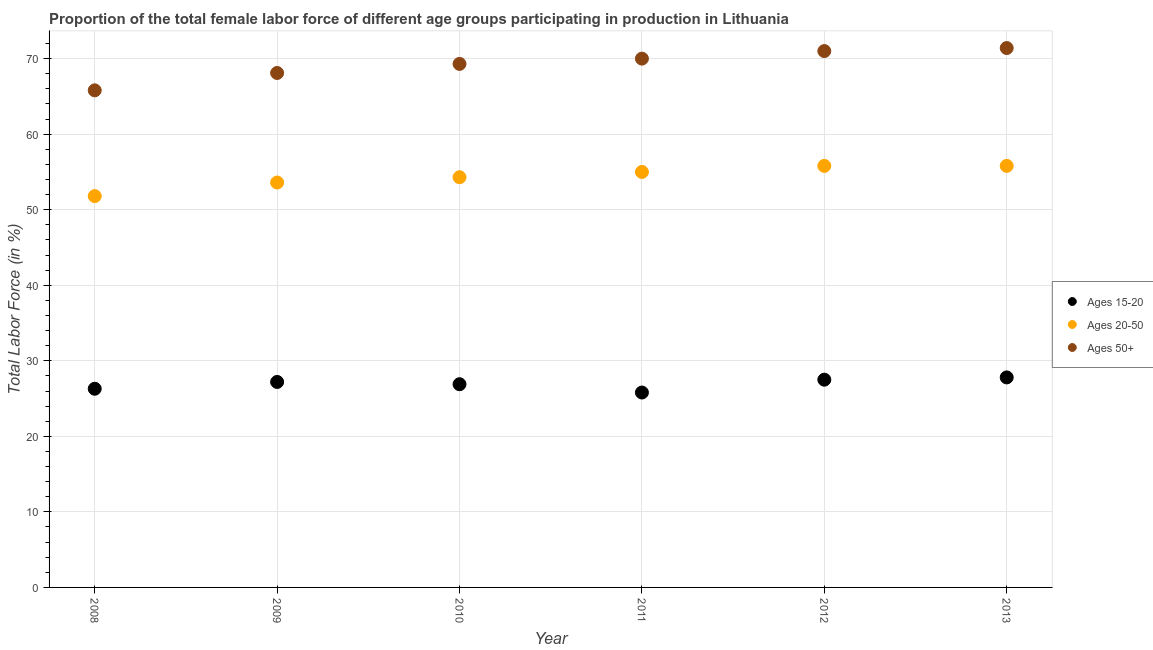How many different coloured dotlines are there?
Make the answer very short. 3. What is the percentage of female labor force within the age group 15-20 in 2011?
Provide a succinct answer. 25.8. Across all years, what is the maximum percentage of female labor force within the age group 20-50?
Your answer should be very brief. 55.8. Across all years, what is the minimum percentage of female labor force above age 50?
Your response must be concise. 65.8. What is the total percentage of female labor force above age 50 in the graph?
Your answer should be compact. 415.6. What is the difference between the percentage of female labor force within the age group 20-50 in 2009 and that in 2010?
Provide a succinct answer. -0.7. What is the difference between the percentage of female labor force within the age group 15-20 in 2008 and the percentage of female labor force within the age group 20-50 in 2009?
Give a very brief answer. -27.3. What is the average percentage of female labor force within the age group 15-20 per year?
Your response must be concise. 26.92. In the year 2012, what is the difference between the percentage of female labor force within the age group 20-50 and percentage of female labor force above age 50?
Offer a terse response. -15.2. What is the ratio of the percentage of female labor force within the age group 20-50 in 2008 to that in 2013?
Provide a succinct answer. 0.93. Is the percentage of female labor force above age 50 in 2011 less than that in 2012?
Make the answer very short. Yes. What is the difference between the highest and the second highest percentage of female labor force within the age group 15-20?
Offer a terse response. 0.3. What is the difference between the highest and the lowest percentage of female labor force within the age group 15-20?
Give a very brief answer. 2. Is the sum of the percentage of female labor force within the age group 15-20 in 2008 and 2011 greater than the maximum percentage of female labor force within the age group 20-50 across all years?
Your answer should be compact. No. Does the percentage of female labor force within the age group 15-20 monotonically increase over the years?
Give a very brief answer. No. Is the percentage of female labor force within the age group 20-50 strictly greater than the percentage of female labor force within the age group 15-20 over the years?
Make the answer very short. Yes. What is the difference between two consecutive major ticks on the Y-axis?
Give a very brief answer. 10. Are the values on the major ticks of Y-axis written in scientific E-notation?
Offer a very short reply. No. Where does the legend appear in the graph?
Keep it short and to the point. Center right. How many legend labels are there?
Give a very brief answer. 3. How are the legend labels stacked?
Your response must be concise. Vertical. What is the title of the graph?
Provide a short and direct response. Proportion of the total female labor force of different age groups participating in production in Lithuania. Does "Argument" appear as one of the legend labels in the graph?
Offer a terse response. No. What is the label or title of the X-axis?
Your answer should be very brief. Year. What is the label or title of the Y-axis?
Your answer should be compact. Total Labor Force (in %). What is the Total Labor Force (in %) in Ages 15-20 in 2008?
Keep it short and to the point. 26.3. What is the Total Labor Force (in %) of Ages 20-50 in 2008?
Your answer should be compact. 51.8. What is the Total Labor Force (in %) in Ages 50+ in 2008?
Offer a terse response. 65.8. What is the Total Labor Force (in %) in Ages 15-20 in 2009?
Make the answer very short. 27.2. What is the Total Labor Force (in %) in Ages 20-50 in 2009?
Make the answer very short. 53.6. What is the Total Labor Force (in %) of Ages 50+ in 2009?
Your answer should be compact. 68.1. What is the Total Labor Force (in %) of Ages 15-20 in 2010?
Give a very brief answer. 26.9. What is the Total Labor Force (in %) of Ages 20-50 in 2010?
Provide a short and direct response. 54.3. What is the Total Labor Force (in %) in Ages 50+ in 2010?
Your response must be concise. 69.3. What is the Total Labor Force (in %) in Ages 15-20 in 2011?
Ensure brevity in your answer.  25.8. What is the Total Labor Force (in %) of Ages 20-50 in 2012?
Provide a succinct answer. 55.8. What is the Total Labor Force (in %) in Ages 50+ in 2012?
Your answer should be very brief. 71. What is the Total Labor Force (in %) in Ages 15-20 in 2013?
Provide a succinct answer. 27.8. What is the Total Labor Force (in %) of Ages 20-50 in 2013?
Give a very brief answer. 55.8. What is the Total Labor Force (in %) in Ages 50+ in 2013?
Offer a very short reply. 71.4. Across all years, what is the maximum Total Labor Force (in %) in Ages 15-20?
Your answer should be compact. 27.8. Across all years, what is the maximum Total Labor Force (in %) in Ages 20-50?
Offer a very short reply. 55.8. Across all years, what is the maximum Total Labor Force (in %) in Ages 50+?
Keep it short and to the point. 71.4. Across all years, what is the minimum Total Labor Force (in %) in Ages 15-20?
Keep it short and to the point. 25.8. Across all years, what is the minimum Total Labor Force (in %) in Ages 20-50?
Your answer should be very brief. 51.8. Across all years, what is the minimum Total Labor Force (in %) in Ages 50+?
Make the answer very short. 65.8. What is the total Total Labor Force (in %) in Ages 15-20 in the graph?
Your answer should be compact. 161.5. What is the total Total Labor Force (in %) in Ages 20-50 in the graph?
Offer a terse response. 326.3. What is the total Total Labor Force (in %) of Ages 50+ in the graph?
Make the answer very short. 415.6. What is the difference between the Total Labor Force (in %) of Ages 20-50 in 2008 and that in 2010?
Give a very brief answer. -2.5. What is the difference between the Total Labor Force (in %) in Ages 50+ in 2008 and that in 2010?
Ensure brevity in your answer.  -3.5. What is the difference between the Total Labor Force (in %) of Ages 15-20 in 2008 and that in 2011?
Provide a short and direct response. 0.5. What is the difference between the Total Labor Force (in %) in Ages 50+ in 2008 and that in 2012?
Your answer should be compact. -5.2. What is the difference between the Total Labor Force (in %) of Ages 15-20 in 2009 and that in 2010?
Your answer should be very brief. 0.3. What is the difference between the Total Labor Force (in %) of Ages 20-50 in 2009 and that in 2010?
Your answer should be compact. -0.7. What is the difference between the Total Labor Force (in %) of Ages 50+ in 2009 and that in 2010?
Your answer should be compact. -1.2. What is the difference between the Total Labor Force (in %) of Ages 15-20 in 2009 and that in 2011?
Provide a succinct answer. 1.4. What is the difference between the Total Labor Force (in %) in Ages 50+ in 2009 and that in 2011?
Give a very brief answer. -1.9. What is the difference between the Total Labor Force (in %) of Ages 20-50 in 2009 and that in 2012?
Your response must be concise. -2.2. What is the difference between the Total Labor Force (in %) in Ages 50+ in 2009 and that in 2012?
Your response must be concise. -2.9. What is the difference between the Total Labor Force (in %) in Ages 20-50 in 2009 and that in 2013?
Offer a very short reply. -2.2. What is the difference between the Total Labor Force (in %) of Ages 50+ in 2009 and that in 2013?
Offer a terse response. -3.3. What is the difference between the Total Labor Force (in %) of Ages 20-50 in 2010 and that in 2011?
Provide a short and direct response. -0.7. What is the difference between the Total Labor Force (in %) in Ages 50+ in 2010 and that in 2011?
Provide a succinct answer. -0.7. What is the difference between the Total Labor Force (in %) of Ages 50+ in 2010 and that in 2012?
Your answer should be compact. -1.7. What is the difference between the Total Labor Force (in %) in Ages 20-50 in 2010 and that in 2013?
Make the answer very short. -1.5. What is the difference between the Total Labor Force (in %) of Ages 15-20 in 2011 and that in 2012?
Your answer should be compact. -1.7. What is the difference between the Total Labor Force (in %) of Ages 50+ in 2011 and that in 2012?
Offer a very short reply. -1. What is the difference between the Total Labor Force (in %) of Ages 50+ in 2011 and that in 2013?
Your response must be concise. -1.4. What is the difference between the Total Labor Force (in %) in Ages 20-50 in 2012 and that in 2013?
Keep it short and to the point. 0. What is the difference between the Total Labor Force (in %) in Ages 15-20 in 2008 and the Total Labor Force (in %) in Ages 20-50 in 2009?
Your answer should be compact. -27.3. What is the difference between the Total Labor Force (in %) of Ages 15-20 in 2008 and the Total Labor Force (in %) of Ages 50+ in 2009?
Your response must be concise. -41.8. What is the difference between the Total Labor Force (in %) in Ages 20-50 in 2008 and the Total Labor Force (in %) in Ages 50+ in 2009?
Make the answer very short. -16.3. What is the difference between the Total Labor Force (in %) in Ages 15-20 in 2008 and the Total Labor Force (in %) in Ages 50+ in 2010?
Your answer should be very brief. -43. What is the difference between the Total Labor Force (in %) of Ages 20-50 in 2008 and the Total Labor Force (in %) of Ages 50+ in 2010?
Provide a short and direct response. -17.5. What is the difference between the Total Labor Force (in %) of Ages 15-20 in 2008 and the Total Labor Force (in %) of Ages 20-50 in 2011?
Offer a terse response. -28.7. What is the difference between the Total Labor Force (in %) in Ages 15-20 in 2008 and the Total Labor Force (in %) in Ages 50+ in 2011?
Your answer should be very brief. -43.7. What is the difference between the Total Labor Force (in %) in Ages 20-50 in 2008 and the Total Labor Force (in %) in Ages 50+ in 2011?
Provide a succinct answer. -18.2. What is the difference between the Total Labor Force (in %) in Ages 15-20 in 2008 and the Total Labor Force (in %) in Ages 20-50 in 2012?
Your answer should be compact. -29.5. What is the difference between the Total Labor Force (in %) of Ages 15-20 in 2008 and the Total Labor Force (in %) of Ages 50+ in 2012?
Your answer should be compact. -44.7. What is the difference between the Total Labor Force (in %) in Ages 20-50 in 2008 and the Total Labor Force (in %) in Ages 50+ in 2012?
Keep it short and to the point. -19.2. What is the difference between the Total Labor Force (in %) of Ages 15-20 in 2008 and the Total Labor Force (in %) of Ages 20-50 in 2013?
Give a very brief answer. -29.5. What is the difference between the Total Labor Force (in %) in Ages 15-20 in 2008 and the Total Labor Force (in %) in Ages 50+ in 2013?
Your answer should be very brief. -45.1. What is the difference between the Total Labor Force (in %) of Ages 20-50 in 2008 and the Total Labor Force (in %) of Ages 50+ in 2013?
Your answer should be compact. -19.6. What is the difference between the Total Labor Force (in %) in Ages 15-20 in 2009 and the Total Labor Force (in %) in Ages 20-50 in 2010?
Your answer should be compact. -27.1. What is the difference between the Total Labor Force (in %) of Ages 15-20 in 2009 and the Total Labor Force (in %) of Ages 50+ in 2010?
Provide a short and direct response. -42.1. What is the difference between the Total Labor Force (in %) in Ages 20-50 in 2009 and the Total Labor Force (in %) in Ages 50+ in 2010?
Ensure brevity in your answer.  -15.7. What is the difference between the Total Labor Force (in %) of Ages 15-20 in 2009 and the Total Labor Force (in %) of Ages 20-50 in 2011?
Offer a very short reply. -27.8. What is the difference between the Total Labor Force (in %) in Ages 15-20 in 2009 and the Total Labor Force (in %) in Ages 50+ in 2011?
Your response must be concise. -42.8. What is the difference between the Total Labor Force (in %) in Ages 20-50 in 2009 and the Total Labor Force (in %) in Ages 50+ in 2011?
Provide a succinct answer. -16.4. What is the difference between the Total Labor Force (in %) of Ages 15-20 in 2009 and the Total Labor Force (in %) of Ages 20-50 in 2012?
Give a very brief answer. -28.6. What is the difference between the Total Labor Force (in %) of Ages 15-20 in 2009 and the Total Labor Force (in %) of Ages 50+ in 2012?
Your answer should be very brief. -43.8. What is the difference between the Total Labor Force (in %) of Ages 20-50 in 2009 and the Total Labor Force (in %) of Ages 50+ in 2012?
Keep it short and to the point. -17.4. What is the difference between the Total Labor Force (in %) of Ages 15-20 in 2009 and the Total Labor Force (in %) of Ages 20-50 in 2013?
Provide a short and direct response. -28.6. What is the difference between the Total Labor Force (in %) in Ages 15-20 in 2009 and the Total Labor Force (in %) in Ages 50+ in 2013?
Give a very brief answer. -44.2. What is the difference between the Total Labor Force (in %) of Ages 20-50 in 2009 and the Total Labor Force (in %) of Ages 50+ in 2013?
Offer a very short reply. -17.8. What is the difference between the Total Labor Force (in %) of Ages 15-20 in 2010 and the Total Labor Force (in %) of Ages 20-50 in 2011?
Your response must be concise. -28.1. What is the difference between the Total Labor Force (in %) of Ages 15-20 in 2010 and the Total Labor Force (in %) of Ages 50+ in 2011?
Your answer should be compact. -43.1. What is the difference between the Total Labor Force (in %) in Ages 20-50 in 2010 and the Total Labor Force (in %) in Ages 50+ in 2011?
Provide a succinct answer. -15.7. What is the difference between the Total Labor Force (in %) in Ages 15-20 in 2010 and the Total Labor Force (in %) in Ages 20-50 in 2012?
Your response must be concise. -28.9. What is the difference between the Total Labor Force (in %) of Ages 15-20 in 2010 and the Total Labor Force (in %) of Ages 50+ in 2012?
Give a very brief answer. -44.1. What is the difference between the Total Labor Force (in %) of Ages 20-50 in 2010 and the Total Labor Force (in %) of Ages 50+ in 2012?
Your response must be concise. -16.7. What is the difference between the Total Labor Force (in %) of Ages 15-20 in 2010 and the Total Labor Force (in %) of Ages 20-50 in 2013?
Your answer should be compact. -28.9. What is the difference between the Total Labor Force (in %) in Ages 15-20 in 2010 and the Total Labor Force (in %) in Ages 50+ in 2013?
Your answer should be compact. -44.5. What is the difference between the Total Labor Force (in %) of Ages 20-50 in 2010 and the Total Labor Force (in %) of Ages 50+ in 2013?
Provide a succinct answer. -17.1. What is the difference between the Total Labor Force (in %) of Ages 15-20 in 2011 and the Total Labor Force (in %) of Ages 20-50 in 2012?
Offer a very short reply. -30. What is the difference between the Total Labor Force (in %) of Ages 15-20 in 2011 and the Total Labor Force (in %) of Ages 50+ in 2012?
Provide a succinct answer. -45.2. What is the difference between the Total Labor Force (in %) of Ages 20-50 in 2011 and the Total Labor Force (in %) of Ages 50+ in 2012?
Provide a succinct answer. -16. What is the difference between the Total Labor Force (in %) of Ages 15-20 in 2011 and the Total Labor Force (in %) of Ages 50+ in 2013?
Give a very brief answer. -45.6. What is the difference between the Total Labor Force (in %) of Ages 20-50 in 2011 and the Total Labor Force (in %) of Ages 50+ in 2013?
Keep it short and to the point. -16.4. What is the difference between the Total Labor Force (in %) of Ages 15-20 in 2012 and the Total Labor Force (in %) of Ages 20-50 in 2013?
Give a very brief answer. -28.3. What is the difference between the Total Labor Force (in %) of Ages 15-20 in 2012 and the Total Labor Force (in %) of Ages 50+ in 2013?
Give a very brief answer. -43.9. What is the difference between the Total Labor Force (in %) in Ages 20-50 in 2012 and the Total Labor Force (in %) in Ages 50+ in 2013?
Offer a very short reply. -15.6. What is the average Total Labor Force (in %) in Ages 15-20 per year?
Your answer should be compact. 26.92. What is the average Total Labor Force (in %) in Ages 20-50 per year?
Give a very brief answer. 54.38. What is the average Total Labor Force (in %) in Ages 50+ per year?
Your answer should be very brief. 69.27. In the year 2008, what is the difference between the Total Labor Force (in %) of Ages 15-20 and Total Labor Force (in %) of Ages 20-50?
Make the answer very short. -25.5. In the year 2008, what is the difference between the Total Labor Force (in %) of Ages 15-20 and Total Labor Force (in %) of Ages 50+?
Make the answer very short. -39.5. In the year 2009, what is the difference between the Total Labor Force (in %) in Ages 15-20 and Total Labor Force (in %) in Ages 20-50?
Your answer should be compact. -26.4. In the year 2009, what is the difference between the Total Labor Force (in %) of Ages 15-20 and Total Labor Force (in %) of Ages 50+?
Make the answer very short. -40.9. In the year 2009, what is the difference between the Total Labor Force (in %) of Ages 20-50 and Total Labor Force (in %) of Ages 50+?
Keep it short and to the point. -14.5. In the year 2010, what is the difference between the Total Labor Force (in %) of Ages 15-20 and Total Labor Force (in %) of Ages 20-50?
Your answer should be compact. -27.4. In the year 2010, what is the difference between the Total Labor Force (in %) of Ages 15-20 and Total Labor Force (in %) of Ages 50+?
Offer a terse response. -42.4. In the year 2011, what is the difference between the Total Labor Force (in %) in Ages 15-20 and Total Labor Force (in %) in Ages 20-50?
Provide a short and direct response. -29.2. In the year 2011, what is the difference between the Total Labor Force (in %) of Ages 15-20 and Total Labor Force (in %) of Ages 50+?
Your answer should be compact. -44.2. In the year 2012, what is the difference between the Total Labor Force (in %) of Ages 15-20 and Total Labor Force (in %) of Ages 20-50?
Give a very brief answer. -28.3. In the year 2012, what is the difference between the Total Labor Force (in %) in Ages 15-20 and Total Labor Force (in %) in Ages 50+?
Provide a succinct answer. -43.5. In the year 2012, what is the difference between the Total Labor Force (in %) in Ages 20-50 and Total Labor Force (in %) in Ages 50+?
Keep it short and to the point. -15.2. In the year 2013, what is the difference between the Total Labor Force (in %) in Ages 15-20 and Total Labor Force (in %) in Ages 50+?
Offer a terse response. -43.6. In the year 2013, what is the difference between the Total Labor Force (in %) of Ages 20-50 and Total Labor Force (in %) of Ages 50+?
Keep it short and to the point. -15.6. What is the ratio of the Total Labor Force (in %) in Ages 15-20 in 2008 to that in 2009?
Provide a short and direct response. 0.97. What is the ratio of the Total Labor Force (in %) in Ages 20-50 in 2008 to that in 2009?
Offer a terse response. 0.97. What is the ratio of the Total Labor Force (in %) of Ages 50+ in 2008 to that in 2009?
Give a very brief answer. 0.97. What is the ratio of the Total Labor Force (in %) of Ages 15-20 in 2008 to that in 2010?
Ensure brevity in your answer.  0.98. What is the ratio of the Total Labor Force (in %) in Ages 20-50 in 2008 to that in 2010?
Ensure brevity in your answer.  0.95. What is the ratio of the Total Labor Force (in %) of Ages 50+ in 2008 to that in 2010?
Your answer should be very brief. 0.95. What is the ratio of the Total Labor Force (in %) in Ages 15-20 in 2008 to that in 2011?
Your answer should be compact. 1.02. What is the ratio of the Total Labor Force (in %) of Ages 20-50 in 2008 to that in 2011?
Offer a terse response. 0.94. What is the ratio of the Total Labor Force (in %) in Ages 15-20 in 2008 to that in 2012?
Your response must be concise. 0.96. What is the ratio of the Total Labor Force (in %) of Ages 20-50 in 2008 to that in 2012?
Offer a very short reply. 0.93. What is the ratio of the Total Labor Force (in %) in Ages 50+ in 2008 to that in 2012?
Keep it short and to the point. 0.93. What is the ratio of the Total Labor Force (in %) of Ages 15-20 in 2008 to that in 2013?
Ensure brevity in your answer.  0.95. What is the ratio of the Total Labor Force (in %) in Ages 20-50 in 2008 to that in 2013?
Ensure brevity in your answer.  0.93. What is the ratio of the Total Labor Force (in %) of Ages 50+ in 2008 to that in 2013?
Keep it short and to the point. 0.92. What is the ratio of the Total Labor Force (in %) in Ages 15-20 in 2009 to that in 2010?
Your response must be concise. 1.01. What is the ratio of the Total Labor Force (in %) in Ages 20-50 in 2009 to that in 2010?
Offer a terse response. 0.99. What is the ratio of the Total Labor Force (in %) of Ages 50+ in 2009 to that in 2010?
Your response must be concise. 0.98. What is the ratio of the Total Labor Force (in %) of Ages 15-20 in 2009 to that in 2011?
Offer a terse response. 1.05. What is the ratio of the Total Labor Force (in %) in Ages 20-50 in 2009 to that in 2011?
Provide a succinct answer. 0.97. What is the ratio of the Total Labor Force (in %) of Ages 50+ in 2009 to that in 2011?
Ensure brevity in your answer.  0.97. What is the ratio of the Total Labor Force (in %) in Ages 20-50 in 2009 to that in 2012?
Provide a succinct answer. 0.96. What is the ratio of the Total Labor Force (in %) of Ages 50+ in 2009 to that in 2012?
Your answer should be very brief. 0.96. What is the ratio of the Total Labor Force (in %) in Ages 15-20 in 2009 to that in 2013?
Make the answer very short. 0.98. What is the ratio of the Total Labor Force (in %) of Ages 20-50 in 2009 to that in 2013?
Keep it short and to the point. 0.96. What is the ratio of the Total Labor Force (in %) in Ages 50+ in 2009 to that in 2013?
Make the answer very short. 0.95. What is the ratio of the Total Labor Force (in %) of Ages 15-20 in 2010 to that in 2011?
Keep it short and to the point. 1.04. What is the ratio of the Total Labor Force (in %) of Ages 20-50 in 2010 to that in 2011?
Give a very brief answer. 0.99. What is the ratio of the Total Labor Force (in %) of Ages 50+ in 2010 to that in 2011?
Make the answer very short. 0.99. What is the ratio of the Total Labor Force (in %) of Ages 15-20 in 2010 to that in 2012?
Make the answer very short. 0.98. What is the ratio of the Total Labor Force (in %) in Ages 20-50 in 2010 to that in 2012?
Offer a terse response. 0.97. What is the ratio of the Total Labor Force (in %) in Ages 50+ in 2010 to that in 2012?
Offer a very short reply. 0.98. What is the ratio of the Total Labor Force (in %) in Ages 15-20 in 2010 to that in 2013?
Offer a very short reply. 0.97. What is the ratio of the Total Labor Force (in %) of Ages 20-50 in 2010 to that in 2013?
Ensure brevity in your answer.  0.97. What is the ratio of the Total Labor Force (in %) of Ages 50+ in 2010 to that in 2013?
Offer a terse response. 0.97. What is the ratio of the Total Labor Force (in %) in Ages 15-20 in 2011 to that in 2012?
Keep it short and to the point. 0.94. What is the ratio of the Total Labor Force (in %) in Ages 20-50 in 2011 to that in 2012?
Keep it short and to the point. 0.99. What is the ratio of the Total Labor Force (in %) in Ages 50+ in 2011 to that in 2012?
Provide a succinct answer. 0.99. What is the ratio of the Total Labor Force (in %) of Ages 15-20 in 2011 to that in 2013?
Make the answer very short. 0.93. What is the ratio of the Total Labor Force (in %) in Ages 20-50 in 2011 to that in 2013?
Provide a short and direct response. 0.99. What is the ratio of the Total Labor Force (in %) in Ages 50+ in 2011 to that in 2013?
Offer a very short reply. 0.98. What is the difference between the highest and the second highest Total Labor Force (in %) in Ages 15-20?
Give a very brief answer. 0.3. What is the difference between the highest and the second highest Total Labor Force (in %) in Ages 50+?
Your answer should be very brief. 0.4. What is the difference between the highest and the lowest Total Labor Force (in %) in Ages 15-20?
Offer a very short reply. 2. What is the difference between the highest and the lowest Total Labor Force (in %) in Ages 20-50?
Your answer should be very brief. 4. What is the difference between the highest and the lowest Total Labor Force (in %) of Ages 50+?
Your answer should be compact. 5.6. 